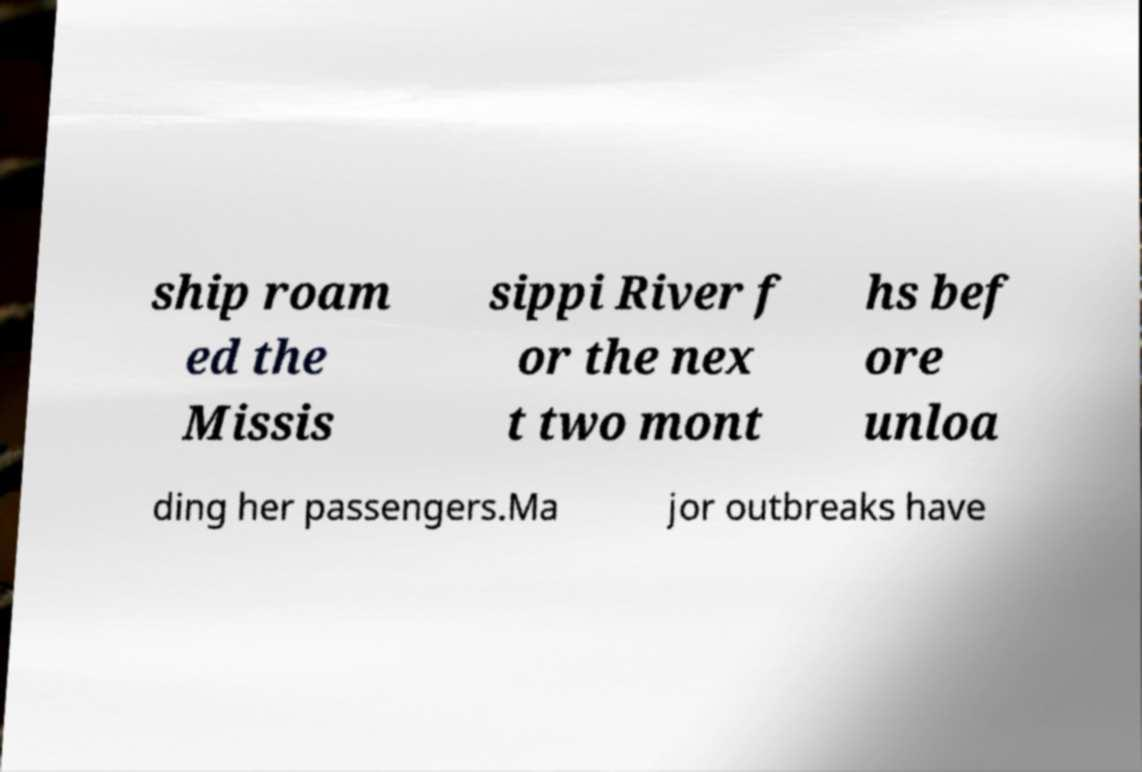Could you assist in decoding the text presented in this image and type it out clearly? ship roam ed the Missis sippi River f or the nex t two mont hs bef ore unloa ding her passengers.Ma jor outbreaks have 